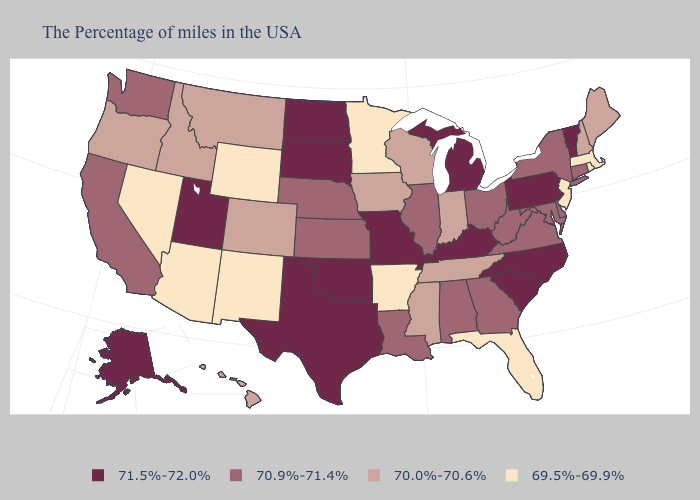What is the value of Colorado?
Short answer required. 70.0%-70.6%. Which states hav the highest value in the Northeast?
Give a very brief answer. Vermont, Pennsylvania. What is the value of Mississippi?
Be succinct. 70.0%-70.6%. What is the value of Kentucky?
Keep it brief. 71.5%-72.0%. What is the value of Hawaii?
Answer briefly. 70.0%-70.6%. Which states have the highest value in the USA?
Keep it brief. Vermont, Pennsylvania, North Carolina, South Carolina, Michigan, Kentucky, Missouri, Oklahoma, Texas, South Dakota, North Dakota, Utah, Alaska. What is the lowest value in the MidWest?
Quick response, please. 69.5%-69.9%. Name the states that have a value in the range 71.5%-72.0%?
Be succinct. Vermont, Pennsylvania, North Carolina, South Carolina, Michigan, Kentucky, Missouri, Oklahoma, Texas, South Dakota, North Dakota, Utah, Alaska. Does California have the highest value in the USA?
Be succinct. No. What is the value of Utah?
Concise answer only. 71.5%-72.0%. Name the states that have a value in the range 71.5%-72.0%?
Keep it brief. Vermont, Pennsylvania, North Carolina, South Carolina, Michigan, Kentucky, Missouri, Oklahoma, Texas, South Dakota, North Dakota, Utah, Alaska. Name the states that have a value in the range 69.5%-69.9%?
Be succinct. Massachusetts, Rhode Island, New Jersey, Florida, Arkansas, Minnesota, Wyoming, New Mexico, Arizona, Nevada. What is the lowest value in states that border Oklahoma?
Short answer required. 69.5%-69.9%. Name the states that have a value in the range 69.5%-69.9%?
Keep it brief. Massachusetts, Rhode Island, New Jersey, Florida, Arkansas, Minnesota, Wyoming, New Mexico, Arizona, Nevada. Which states have the lowest value in the USA?
Quick response, please. Massachusetts, Rhode Island, New Jersey, Florida, Arkansas, Minnesota, Wyoming, New Mexico, Arizona, Nevada. 